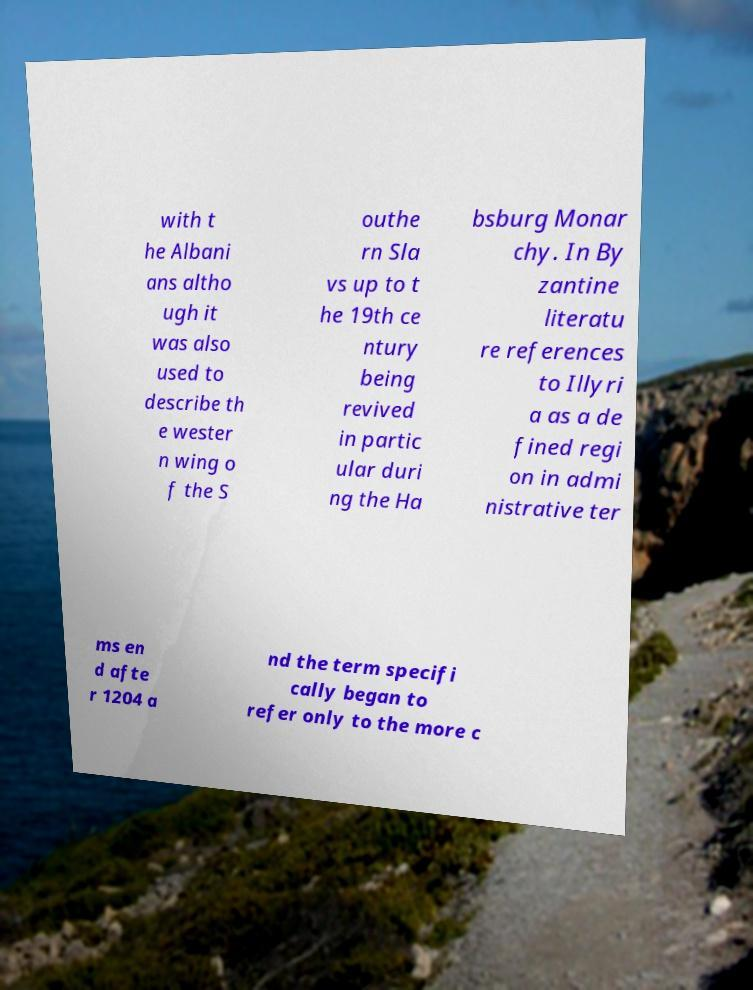Can you read and provide the text displayed in the image?This photo seems to have some interesting text. Can you extract and type it out for me? with t he Albani ans altho ugh it was also used to describe th e wester n wing o f the S outhe rn Sla vs up to t he 19th ce ntury being revived in partic ular duri ng the Ha bsburg Monar chy. In By zantine literatu re references to Illyri a as a de fined regi on in admi nistrative ter ms en d afte r 1204 a nd the term specifi cally began to refer only to the more c 